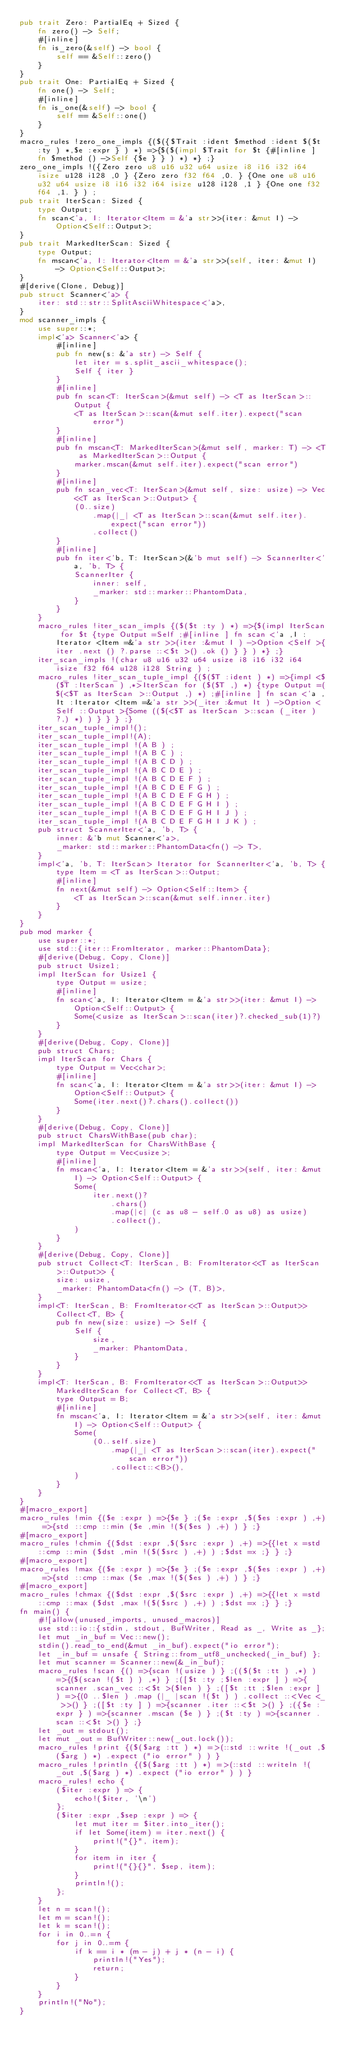Convert code to text. <code><loc_0><loc_0><loc_500><loc_500><_Rust_>pub trait Zero: PartialEq + Sized {
    fn zero() -> Self;
    #[inline]
    fn is_zero(&self) -> bool {
        self == &Self::zero()
    }
}
pub trait One: PartialEq + Sized {
    fn one() -> Self;
    #[inline]
    fn is_one(&self) -> bool {
        self == &Self::one()
    }
}
macro_rules !zero_one_impls {($({$Trait :ident $method :ident $($t :ty ) *,$e :expr } ) *) =>{$($(impl $Trait for $t {#[inline ] fn $method () ->Self {$e } } ) *) *} ;}
zero_one_impls !({Zero zero u8 u16 u32 u64 usize i8 i16 i32 i64 isize u128 i128 ,0 } {Zero zero f32 f64 ,0. } {One one u8 u16 u32 u64 usize i8 i16 i32 i64 isize u128 i128 ,1 } {One one f32 f64 ,1. } ) ;
pub trait IterScan: Sized {
    type Output;
    fn scan<'a, I: Iterator<Item = &'a str>>(iter: &mut I) -> Option<Self::Output>;
}
pub trait MarkedIterScan: Sized {
    type Output;
    fn mscan<'a, I: Iterator<Item = &'a str>>(self, iter: &mut I) -> Option<Self::Output>;
}
#[derive(Clone, Debug)]
pub struct Scanner<'a> {
    iter: std::str::SplitAsciiWhitespace<'a>,
}
mod scanner_impls {
    use super::*;
    impl<'a> Scanner<'a> {
        #[inline]
        pub fn new(s: &'a str) -> Self {
            let iter = s.split_ascii_whitespace();
            Self { iter }
        }
        #[inline]
        pub fn scan<T: IterScan>(&mut self) -> <T as IterScan>::Output {
            <T as IterScan>::scan(&mut self.iter).expect("scan error")
        }
        #[inline]
        pub fn mscan<T: MarkedIterScan>(&mut self, marker: T) -> <T as MarkedIterScan>::Output {
            marker.mscan(&mut self.iter).expect("scan error")
        }
        #[inline]
        pub fn scan_vec<T: IterScan>(&mut self, size: usize) -> Vec<<T as IterScan>::Output> {
            (0..size)
                .map(|_| <T as IterScan>::scan(&mut self.iter).expect("scan error"))
                .collect()
        }
        #[inline]
        pub fn iter<'b, T: IterScan>(&'b mut self) -> ScannerIter<'a, 'b, T> {
            ScannerIter {
                inner: self,
                _marker: std::marker::PhantomData,
            }
        }
    }
    macro_rules !iter_scan_impls {($($t :ty ) *) =>{$(impl IterScan for $t {type Output =Self ;#[inline ] fn scan <'a ,I :Iterator <Item =&'a str >>(iter :&mut I ) ->Option <Self >{iter .next () ?.parse ::<$t >() .ok () } } ) *} ;}
    iter_scan_impls !(char u8 u16 u32 u64 usize i8 i16 i32 i64 isize f32 f64 u128 i128 String ) ;
    macro_rules !iter_scan_tuple_impl {($($T :ident ) *) =>{impl <$($T :IterScan ) ,*>IterScan for ($($T ,) *) {type Output =($(<$T as IterScan >::Output ,) *) ;#[inline ] fn scan <'a ,It :Iterator <Item =&'a str >>(_iter :&mut It ) ->Option <Self ::Output >{Some (($(<$T as IterScan >::scan (_iter ) ?,) *) ) } } } ;}
    iter_scan_tuple_impl!();
    iter_scan_tuple_impl!(A);
    iter_scan_tuple_impl !(A B ) ;
    iter_scan_tuple_impl !(A B C ) ;
    iter_scan_tuple_impl !(A B C D ) ;
    iter_scan_tuple_impl !(A B C D E ) ;
    iter_scan_tuple_impl !(A B C D E F ) ;
    iter_scan_tuple_impl !(A B C D E F G ) ;
    iter_scan_tuple_impl !(A B C D E F G H ) ;
    iter_scan_tuple_impl !(A B C D E F G H I ) ;
    iter_scan_tuple_impl !(A B C D E F G H I J ) ;
    iter_scan_tuple_impl !(A B C D E F G H I J K ) ;
    pub struct ScannerIter<'a, 'b, T> {
        inner: &'b mut Scanner<'a>,
        _marker: std::marker::PhantomData<fn() -> T>,
    }
    impl<'a, 'b, T: IterScan> Iterator for ScannerIter<'a, 'b, T> {
        type Item = <T as IterScan>::Output;
        #[inline]
        fn next(&mut self) -> Option<Self::Item> {
            <T as IterScan>::scan(&mut self.inner.iter)
        }
    }
}
pub mod marker {
    use super::*;
    use std::{iter::FromIterator, marker::PhantomData};
    #[derive(Debug, Copy, Clone)]
    pub struct Usize1;
    impl IterScan for Usize1 {
        type Output = usize;
        #[inline]
        fn scan<'a, I: Iterator<Item = &'a str>>(iter: &mut I) -> Option<Self::Output> {
            Some(<usize as IterScan>::scan(iter)?.checked_sub(1)?)
        }
    }
    #[derive(Debug, Copy, Clone)]
    pub struct Chars;
    impl IterScan for Chars {
        type Output = Vec<char>;
        #[inline]
        fn scan<'a, I: Iterator<Item = &'a str>>(iter: &mut I) -> Option<Self::Output> {
            Some(iter.next()?.chars().collect())
        }
    }
    #[derive(Debug, Copy, Clone)]
    pub struct CharsWithBase(pub char);
    impl MarkedIterScan for CharsWithBase {
        type Output = Vec<usize>;
        #[inline]
        fn mscan<'a, I: Iterator<Item = &'a str>>(self, iter: &mut I) -> Option<Self::Output> {
            Some(
                iter.next()?
                    .chars()
                    .map(|c| (c as u8 - self.0 as u8) as usize)
                    .collect(),
            )
        }
    }
    #[derive(Debug, Copy, Clone)]
    pub struct Collect<T: IterScan, B: FromIterator<<T as IterScan>::Output>> {
        size: usize,
        _marker: PhantomData<fn() -> (T, B)>,
    }
    impl<T: IterScan, B: FromIterator<<T as IterScan>::Output>> Collect<T, B> {
        pub fn new(size: usize) -> Self {
            Self {
                size,
                _marker: PhantomData,
            }
        }
    }
    impl<T: IterScan, B: FromIterator<<T as IterScan>::Output>> MarkedIterScan for Collect<T, B> {
        type Output = B;
        #[inline]
        fn mscan<'a, I: Iterator<Item = &'a str>>(self, iter: &mut I) -> Option<Self::Output> {
            Some(
                (0..self.size)
                    .map(|_| <T as IterScan>::scan(iter).expect("scan error"))
                    .collect::<B>(),
            )
        }
    }
}
#[macro_export]
macro_rules !min {($e :expr ) =>{$e } ;($e :expr ,$($es :expr ) ,+) =>{std ::cmp ::min ($e ,min !($($es ) ,+) ) } ;}
#[macro_export]
macro_rules !chmin {($dst :expr ,$($src :expr ) ,+) =>{{let x =std ::cmp ::min ($dst ,min !($($src ) ,+) ) ;$dst =x ;} } ;}
#[macro_export]
macro_rules !max {($e :expr ) =>{$e } ;($e :expr ,$($es :expr ) ,+) =>{std ::cmp ::max ($e ,max !($($es ) ,+) ) } ;}
#[macro_export]
macro_rules !chmax {($dst :expr ,$($src :expr ) ,+) =>{{let x =std ::cmp ::max ($dst ,max !($($src ) ,+) ) ;$dst =x ;} } ;}
fn main() {
    #![allow(unused_imports, unused_macros)]
    use std::io::{stdin, stdout, BufWriter, Read as _, Write as _};
    let mut _in_buf = Vec::new();
    stdin().read_to_end(&mut _in_buf).expect("io error");
    let _in_buf = unsafe { String::from_utf8_unchecked(_in_buf) };
    let mut scanner = Scanner::new(&_in_buf);
    macro_rules !scan {() =>{scan !(usize ) } ;(($($t :tt ) ,*) ) =>{($(scan !($t ) ) ,*) } ;([$t :ty ;$len :expr ] ) =>{scanner .scan_vec ::<$t >($len ) } ;([$t :tt ;$len :expr ] ) =>{(0 ..$len ) .map (|_ |scan !($t ) ) .collect ::<Vec <_ >>() } ;([$t :ty ] ) =>{scanner .iter ::<$t >() } ;({$e :expr } ) =>{scanner .mscan ($e ) } ;($t :ty ) =>{scanner .scan ::<$t >() } ;}
    let _out = stdout();
    let mut _out = BufWriter::new(_out.lock());
    macro_rules !print {($($arg :tt ) *) =>(::std ::write !(_out ,$($arg ) *) .expect ("io error" ) ) }
    macro_rules !println {($($arg :tt ) *) =>(::std ::writeln !(_out ,$($arg ) *) .expect ("io error" ) ) }
    macro_rules! echo {
        ($iter :expr ) => {
            echo!($iter, '\n')
        };
        ($iter :expr ,$sep :expr ) => {
            let mut iter = $iter.into_iter();
            if let Some(item) = iter.next() {
                print!("{}", item);
            }
            for item in iter {
                print!("{}{}", $sep, item);
            }
            println!();
        };
    }
    let n = scan!();
    let m = scan!();
    let k = scan!();
    for i in 0..=n {
        for j in 0..=m {
            if k == i * (m - j) + j * (n - i) {
                println!("Yes");
                return;
            }
        }
    }
    println!("No");
}</code> 